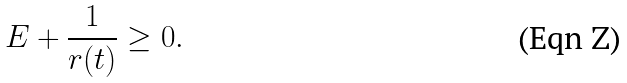Convert formula to latex. <formula><loc_0><loc_0><loc_500><loc_500>E + \frac { 1 } { r ( t ) } \geq 0 .</formula> 